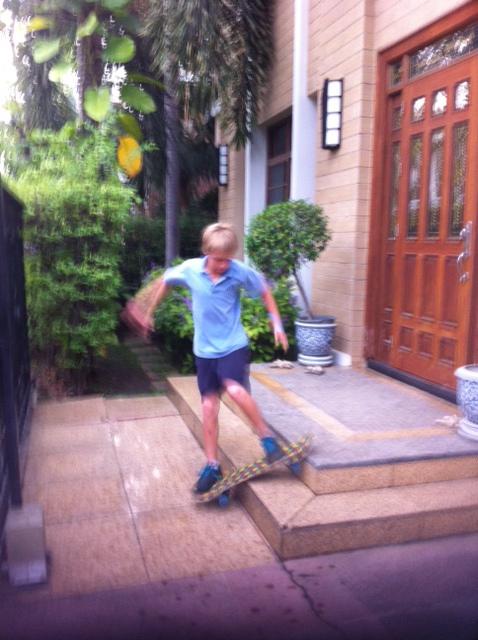What color is the boy's shirt?
Short answer required. Blue. What color shoelaces?
Quick response, please. Blue. How many steps lead to the door?
Quick response, please. 2. 